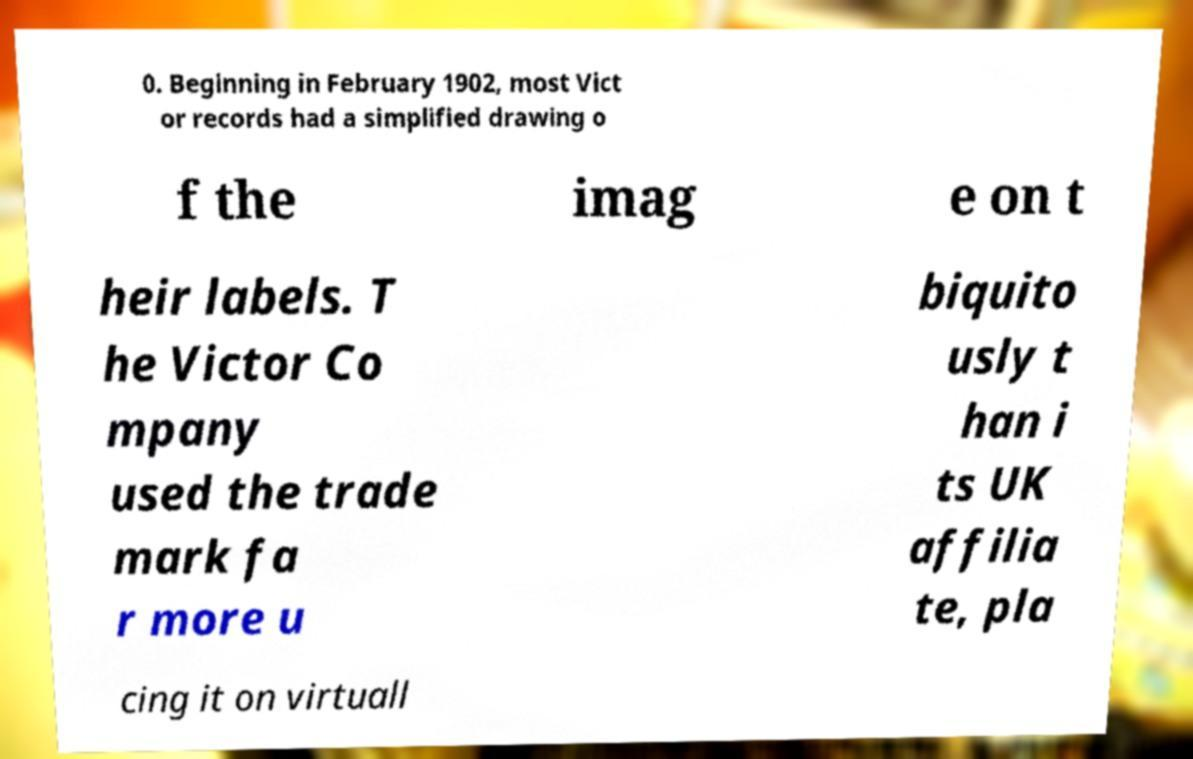For documentation purposes, I need the text within this image transcribed. Could you provide that? 0. Beginning in February 1902, most Vict or records had a simplified drawing o f the imag e on t heir labels. T he Victor Co mpany used the trade mark fa r more u biquito usly t han i ts UK affilia te, pla cing it on virtuall 